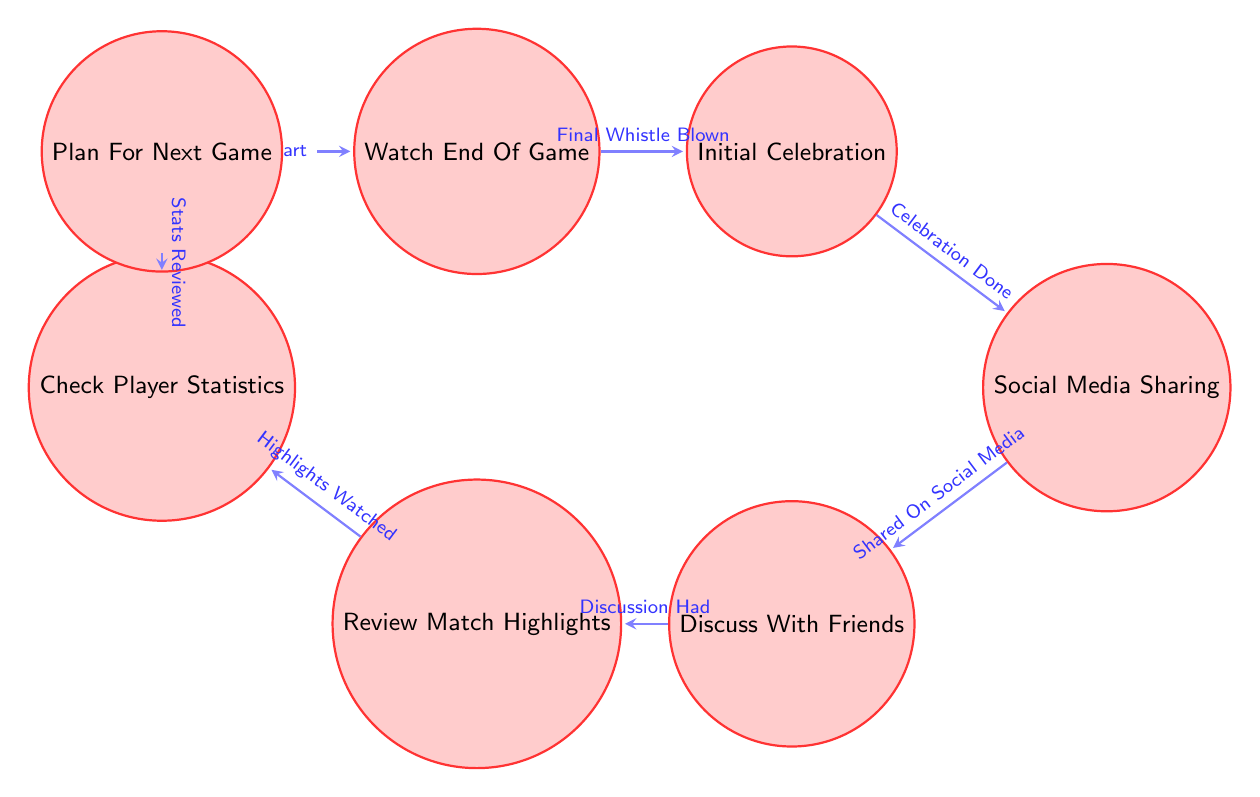What is the first state in the diagram? The first state is "WatchEndOfGame", which is the starting point indicated by being marked as initial.
Answer: WatchEndOfGame How many states are there in total? By counting the states listed in the diagram, there are a total of six states included: WatchEndOfGame, InitialCelebration, SocialMediaSharing, DiscussWithFriends, ReviewMatchHighlights, and CheckPlayerStatistics.
Answer: 7 What transition leads to "InitialCelebration"? The transition that leads to "InitialCelebration" is labeled "Final Whistle Blown", which connects it directly to the state "WatchEndOfGame".
Answer: Final Whistle Blown Which state comes after "DiscussWithFriends"? The state that follows "DiscussWithFriends" in the flow of the diagram is "ReviewMatchHighlights", showing the next action taken after discussing with friends.
Answer: ReviewMatchHighlights What happens after the player statistics are reviewed? After "CheckPlayerStatistics", the transition called "Stats Reviewed" takes the fan to the "PlanForNextGame" state, indicating it’s time to start planning for the next match.
Answer: PlanForNextGame What is the relationship between "SocialMediaSharing" and "DiscussWithFriends"? The relationship between "SocialMediaSharing" and "DiscussWithFriends" is a transition caused by the action "Shared On Social Media", which signifies that the fan will discuss the match after sharing their thoughts online.
Answer: Shared On Social Media What is the final state in the process described? The final state in the sequence reached after going through all transitions is "PlanForNextGame", indicating the conclusion of the fan's celebration and analysis routine.
Answer: PlanForNextGame 